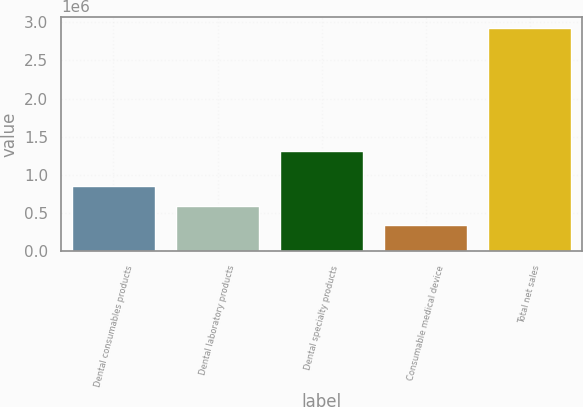Convert chart. <chart><loc_0><loc_0><loc_500><loc_500><bar_chart><fcel>Dental consumables products<fcel>Dental laboratory products<fcel>Dental specialty products<fcel>Consumable medical device<fcel>Total net sales<nl><fcel>854043<fcel>594744<fcel>1.31304e+06<fcel>335446<fcel>2.92843e+06<nl></chart> 